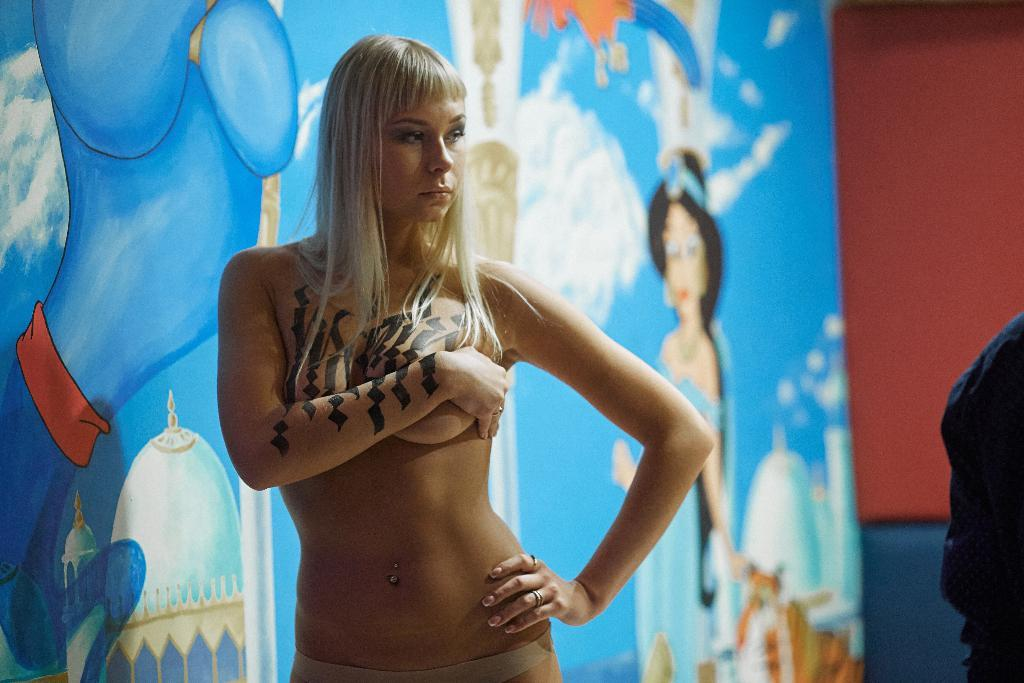What is the main subject of the image? There is a woman standing in the image. What can be seen in the background or beside the woman? There is a painting on a board in the image. Are there any other people in the image? Yes, there is another person standing in the right corner of the image. What type of humor can be seen in the sock that the woman is wearing in the image? There is no sock mentioned in the image, and therefore no humor related to a sock can be observed. 